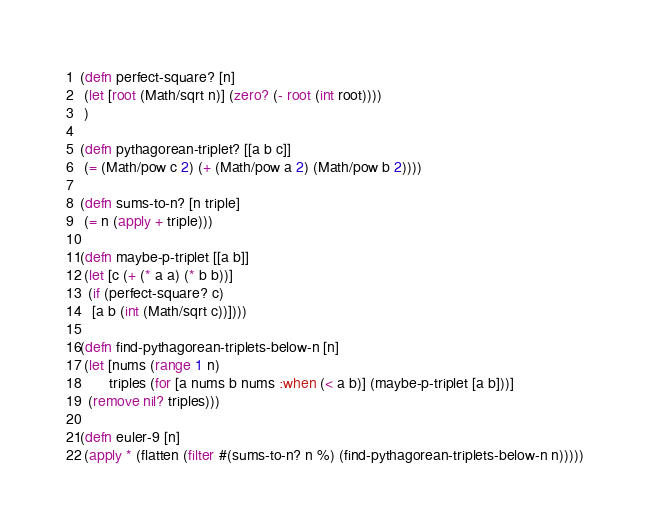Convert code to text. <code><loc_0><loc_0><loc_500><loc_500><_Clojure_>(defn perfect-square? [n]
 (let [root (Math/sqrt n)] (zero? (- root (int root))))
 )

(defn pythagorean-triplet? [[a b c]]
 (= (Math/pow c 2) (+ (Math/pow a 2) (Math/pow b 2))))

(defn sums-to-n? [n triple]
 (= n (apply + triple)))

(defn maybe-p-triplet [[a b]]
 (let [c (+ (* a a) (* b b))]
  (if (perfect-square? c)
   [a b (int (Math/sqrt c))])))

(defn find-pythagorean-triplets-below-n [n]
 (let [nums (range 1 n)
       triples (for [a nums b nums :when (< a b)] (maybe-p-triplet [a b]))]
  (remove nil? triples)))

(defn euler-9 [n]
 (apply * (flatten (filter #(sums-to-n? n %) (find-pythagorean-triplets-below-n n)))))

</code> 